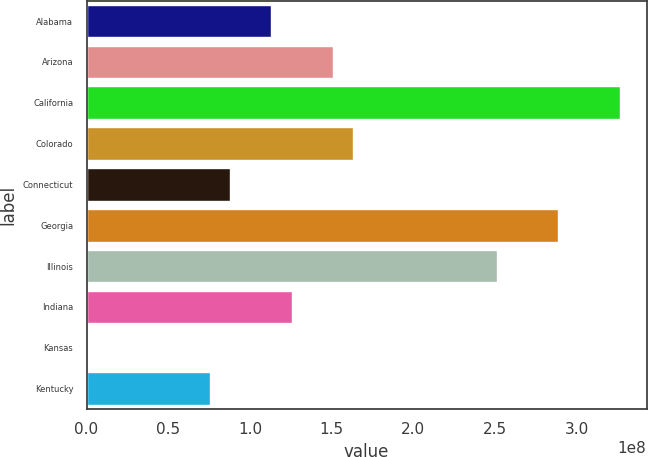Convert chart to OTSL. <chart><loc_0><loc_0><loc_500><loc_500><bar_chart><fcel>Alabama<fcel>Arizona<fcel>California<fcel>Colorado<fcel>Connecticut<fcel>Georgia<fcel>Illinois<fcel>Indiana<fcel>Kansas<fcel>Kentucky<nl><fcel>1.1314e+08<fcel>1.50777e+08<fcel>3.26416e+08<fcel>1.63322e+08<fcel>8.80482e+07<fcel>2.88779e+08<fcel>2.51142e+08<fcel>1.25685e+08<fcel>228489<fcel>7.55026e+07<nl></chart> 